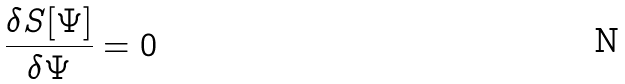Convert formula to latex. <formula><loc_0><loc_0><loc_500><loc_500>\frac { \delta S [ \Psi ] } { \delta \Psi } = 0</formula> 